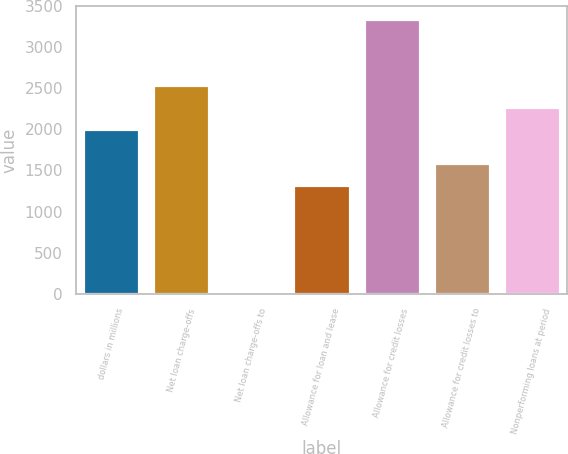Convert chart. <chart><loc_0><loc_0><loc_500><loc_500><bar_chart><fcel>dollars in millions<fcel>Net loan charge-offs<fcel>Net loan charge-offs to<fcel>Allowance for loan and lease<fcel>Allowance for credit losses<fcel>Allowance for credit losses to<fcel>Nonperforming loans at period<nl><fcel>2009<fcel>2539.32<fcel>3.4<fcel>1329.2<fcel>3334.8<fcel>1594.36<fcel>2274.16<nl></chart> 